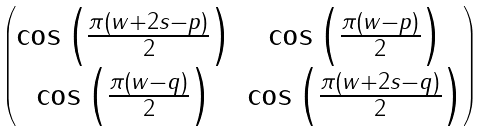<formula> <loc_0><loc_0><loc_500><loc_500>\begin{pmatrix} \cos \left ( \frac { \pi ( w + 2 s - p ) } 2 \right ) & \cos \left ( \frac { \pi ( w - p ) } 2 \right ) \\ \cos \left ( \frac { \pi ( w - q ) } 2 \right ) & \cos \left ( \frac { \pi ( w + 2 s - q ) } 2 \right ) \end{pmatrix}</formula> 